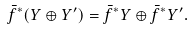<formula> <loc_0><loc_0><loc_500><loc_500>\bar { f } ^ { * } ( Y \oplus Y ^ { \prime } ) = \bar { f } ^ { * } Y \oplus \bar { f } ^ { * } Y ^ { \prime } .</formula> 